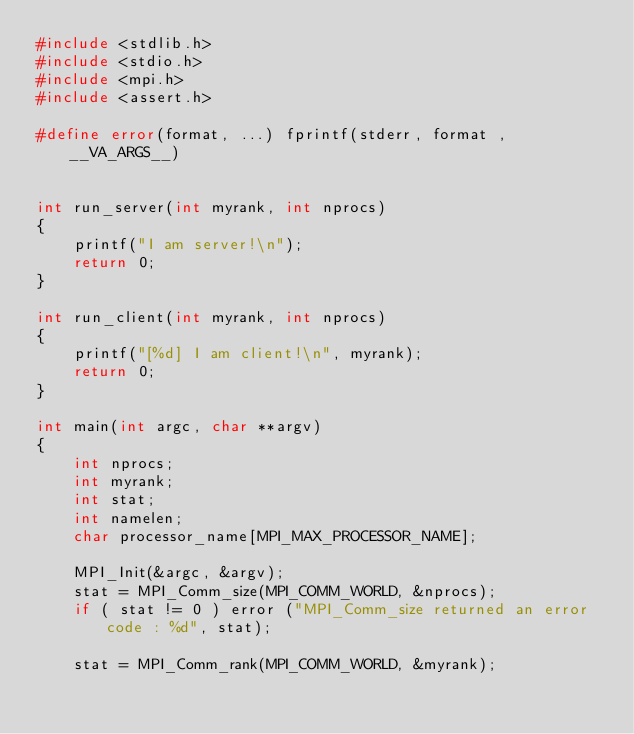Convert code to text. <code><loc_0><loc_0><loc_500><loc_500><_C_>#include <stdlib.h>
#include <stdio.h>
#include <mpi.h>
#include <assert.h>

#define error(format, ...) fprintf(stderr, format , __VA_ARGS__)


int run_server(int myrank, int nprocs)
{
    printf("I am server!\n");
    return 0;
}

int run_client(int myrank, int nprocs)
{
    printf("[%d] I am client!\n", myrank);
    return 0;
}

int main(int argc, char **argv)
{
    int nprocs;
    int myrank;
    int stat;
    int namelen;
    char processor_name[MPI_MAX_PROCESSOR_NAME];

    MPI_Init(&argc, &argv);
    stat = MPI_Comm_size(MPI_COMM_WORLD, &nprocs);
    if ( stat != 0 ) error ("MPI_Comm_size returned an error code : %d", stat);

    stat = MPI_Comm_rank(MPI_COMM_WORLD, &myrank);</code> 